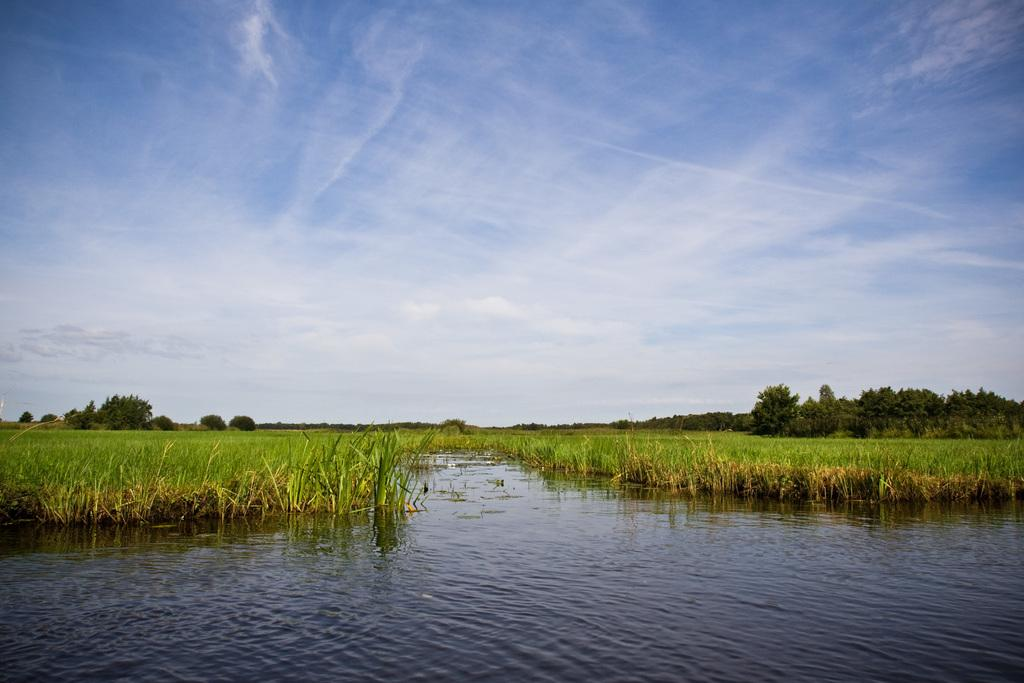What type of vegetation can be seen in the image? There are trees and plants in the image. What is visible at the top of the image? The sky is visible at the top of the image. What is present at the bottom of the image? Water is present at the bottom of the image. What type of glove is being used to stir the stew in the image? There is no glove or stew present in the image. 